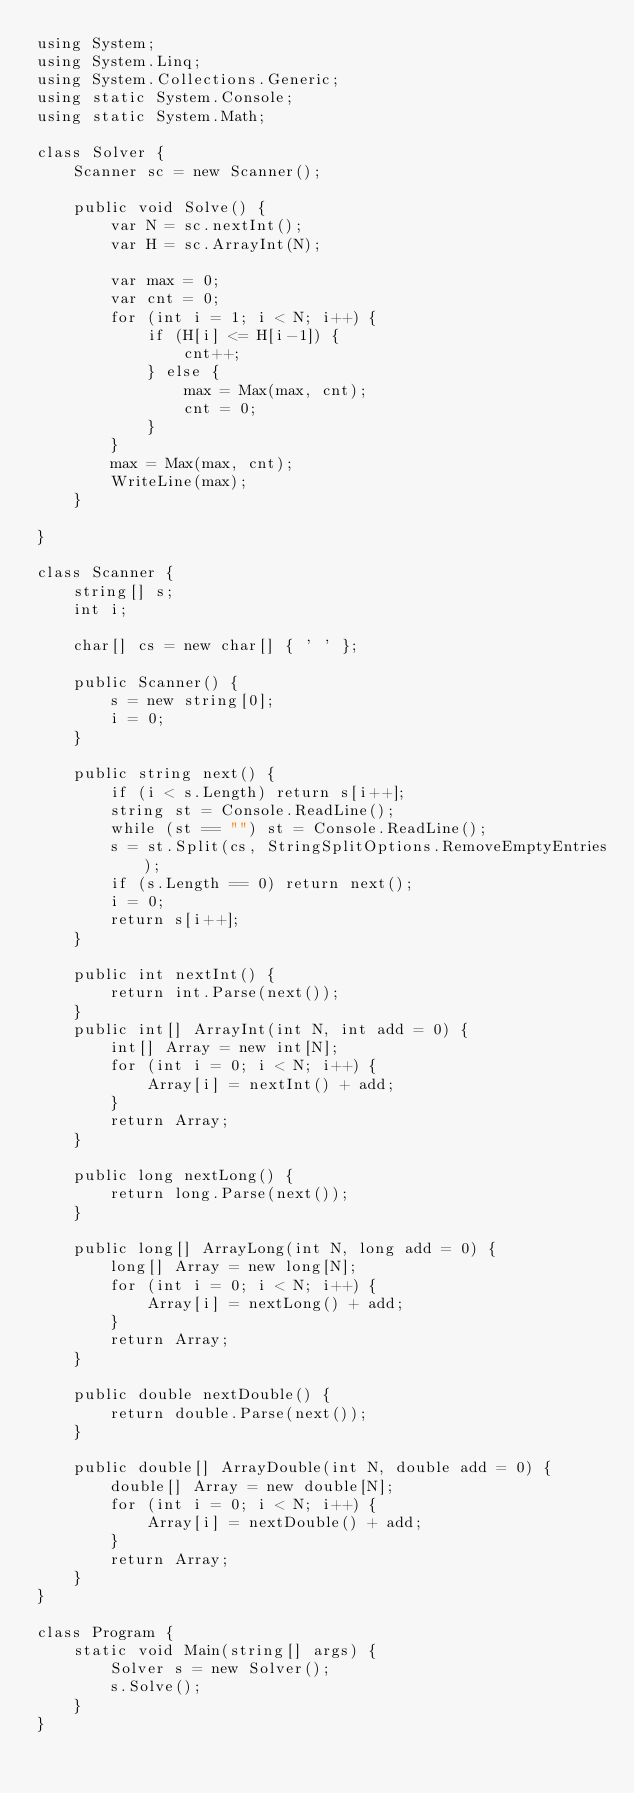<code> <loc_0><loc_0><loc_500><loc_500><_C#_>using System;
using System.Linq;
using System.Collections.Generic;
using static System.Console;
using static System.Math;

class Solver {
    Scanner sc = new Scanner();

    public void Solve() {
        var N = sc.nextInt();
        var H = sc.ArrayInt(N);

        var max = 0;
        var cnt = 0;
        for (int i = 1; i < N; i++) {
            if (H[i] <= H[i-1]) {
                cnt++;
            } else {
                max = Max(max, cnt);
                cnt = 0;
            }
        }
        max = Max(max, cnt);
        WriteLine(max);
    }
    
}

class Scanner {
    string[] s;
    int i;

    char[] cs = new char[] { ' ' };

    public Scanner() {
        s = new string[0];
        i = 0;
    }

    public string next() {
        if (i < s.Length) return s[i++];
        string st = Console.ReadLine();
        while (st == "") st = Console.ReadLine();
        s = st.Split(cs, StringSplitOptions.RemoveEmptyEntries);
        if (s.Length == 0) return next();
        i = 0;
        return s[i++];
    }

    public int nextInt() {
        return int.Parse(next());
    }
    public int[] ArrayInt(int N, int add = 0) {
        int[] Array = new int[N];
        for (int i = 0; i < N; i++) {
            Array[i] = nextInt() + add;
        }
        return Array;
    }

    public long nextLong() {
        return long.Parse(next());
    }

    public long[] ArrayLong(int N, long add = 0) {
        long[] Array = new long[N];
        for (int i = 0; i < N; i++) {
            Array[i] = nextLong() + add;
        }
        return Array;
    }

    public double nextDouble() {
        return double.Parse(next());
    }

    public double[] ArrayDouble(int N, double add = 0) {
        double[] Array = new double[N];
        for (int i = 0; i < N; i++) {
            Array[i] = nextDouble() + add;
        }
        return Array;
    }
}

class Program {
    static void Main(string[] args) {
        Solver s = new Solver();
        s.Solve();
    }
}
</code> 